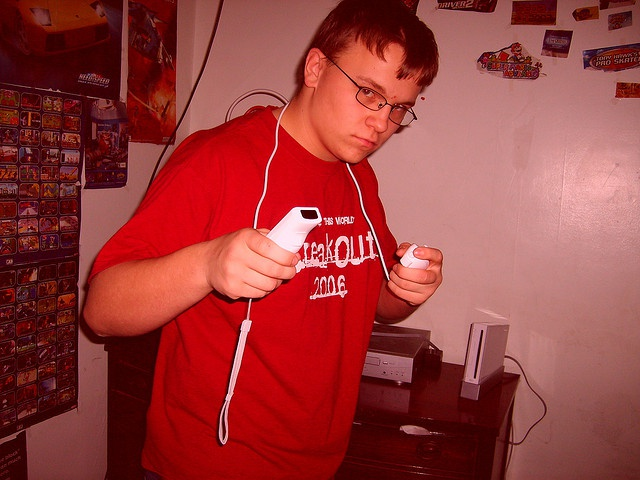Describe the objects in this image and their specific colors. I can see people in maroon, brown, and salmon tones and remote in maroon, lavender, and lightpink tones in this image. 